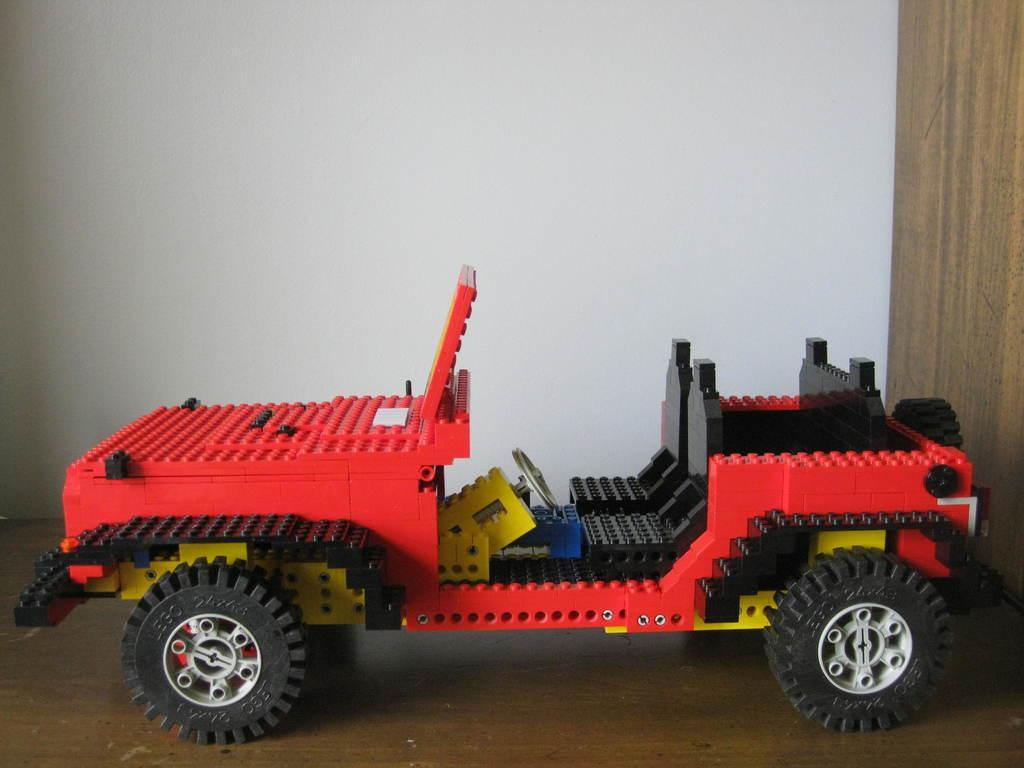Describe this image in one or two sentences. In this image I can see a toy vehicle which is made up of lego on the brown colored surface. In the background I can see the white colored wall. 